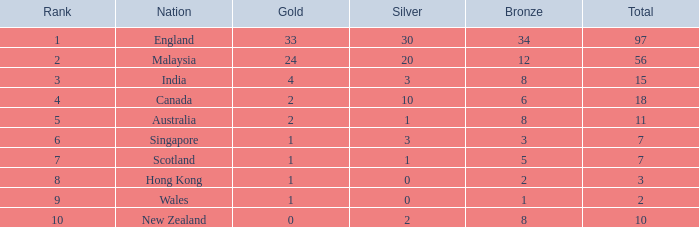What is the total number of bronze a team with more than 0 silver, a total of 7 medals, and less than 1 gold medal has? 0.0. 